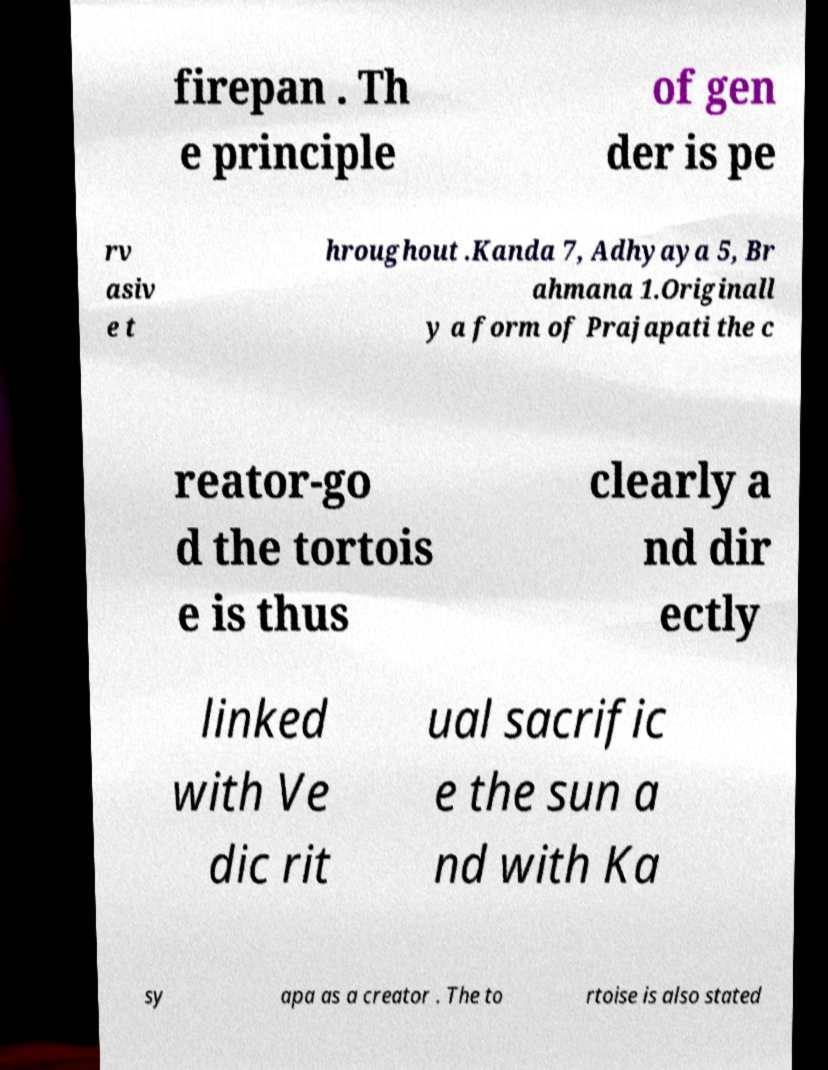For documentation purposes, I need the text within this image transcribed. Could you provide that? firepan . Th e principle of gen der is pe rv asiv e t hroughout .Kanda 7, Adhyaya 5, Br ahmana 1.Originall y a form of Prajapati the c reator-go d the tortois e is thus clearly a nd dir ectly linked with Ve dic rit ual sacrific e the sun a nd with Ka sy apa as a creator . The to rtoise is also stated 